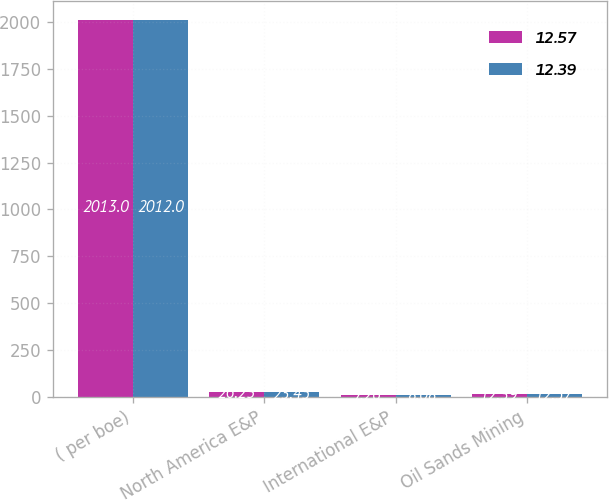Convert chart. <chart><loc_0><loc_0><loc_500><loc_500><stacked_bar_chart><ecel><fcel>( per boe)<fcel>North America E&P<fcel>International E&P<fcel>Oil Sands Mining<nl><fcel>12.57<fcel>2013<fcel>26.23<fcel>7.26<fcel>12.39<nl><fcel>12.39<fcel>2012<fcel>23.45<fcel>8.08<fcel>12.57<nl></chart> 